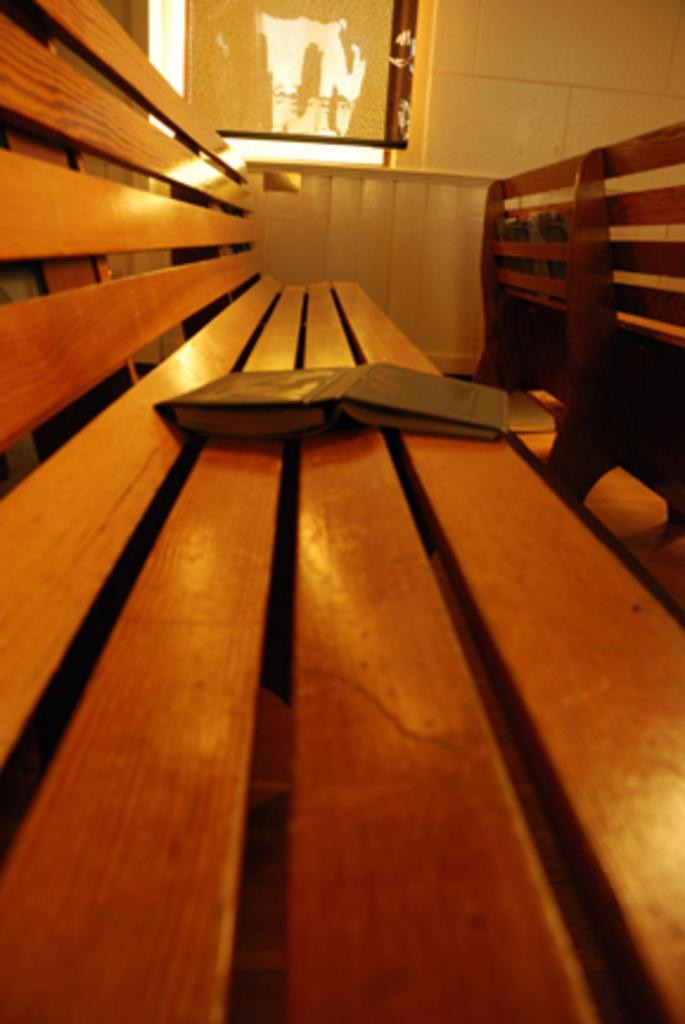What object can be seen in the image that is typically used for reading or learning? There is a book in the image. Where is the book placed? The book is placed on a wooden bench. What can be seen in the background of the image? There is a window and a wall in the image. Are there any other benches visible in the image? Yes, there is another bench on the right side of the image. Can you tell me what the characters in the book are arguing about? There is no information about the content of the book in the image, so it is not possible to determine if there is an argument or what it might be about. 